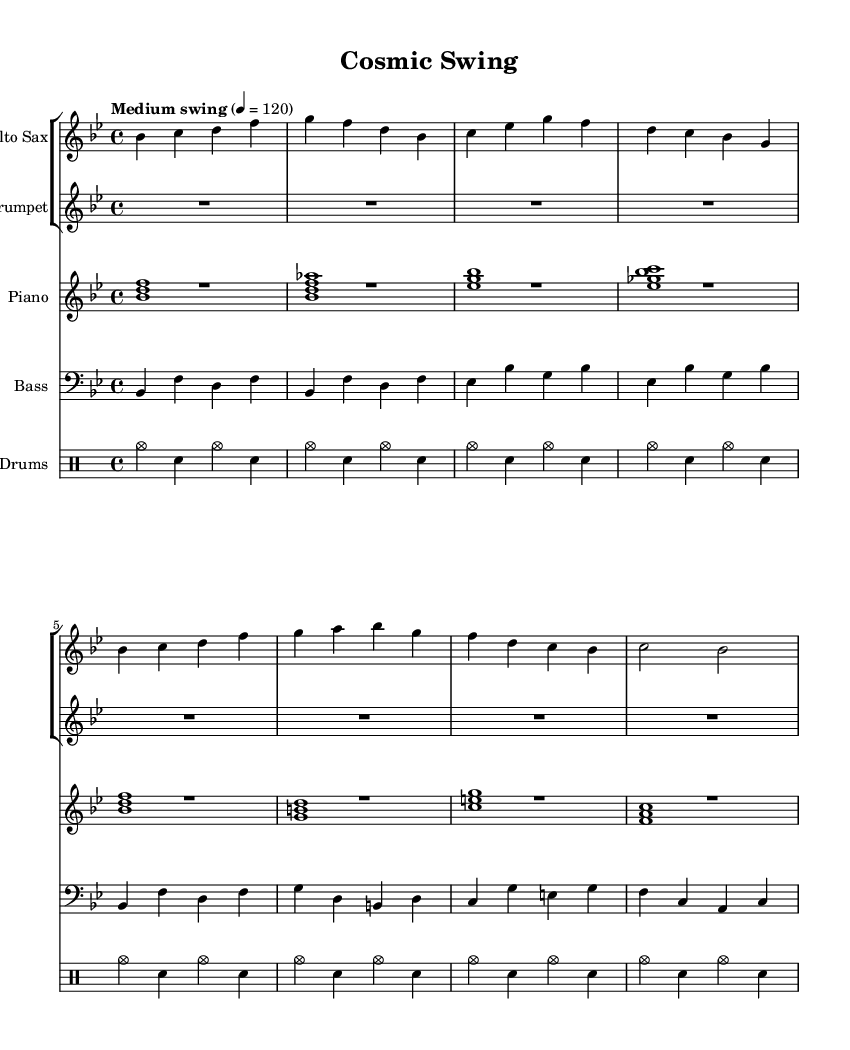What is the key signature of this music? The key signature is B flat major, which has two flats (B flat and E flat). This is indicated at the beginning of the score.
Answer: B flat major What is the time signature of this piece? The time signature is four-four, indicated by the 4/4 notation at the beginning of the score. This means there are four beats per measure.
Answer: 4/4 What is the tempo marking for this piece? The tempo marking, found at the start of the score, states "Medium swing" with a metronome marking of quarter note equals 120, implying a moderate swinging feel appropriate for jazz music.
Answer: Medium swing How many measures are in the alto sax part? To find the number of measures, we can count the bars in the provided music notation for the alto sax. The part consists of eight measures total, indicated by the structure of the notes.
Answer: 8 What is the rhythmic pattern in the drums part? Analyzing the provided drumming line, it consists of a pattern that repeats every four counts with a cymbal hit and snare hits, showcasing a standard jazz drum groove characteristic of the swing style.
Answer: Cymbal and snare Which instrument plays the melody? In this piece, the alto saxophone part predominantly carries the melodic line with its distinct notes that stand out in the score, while other instruments provide harmonic support.
Answer: Alto saxophone What type of chords are used in the piano left hand? The left hand of the piano uses root position and close voicings of major and minor triads, which provide harmonic support and are a common feature in jazz, allowing for rich texture in the accompaniment.
Answer: Triads 